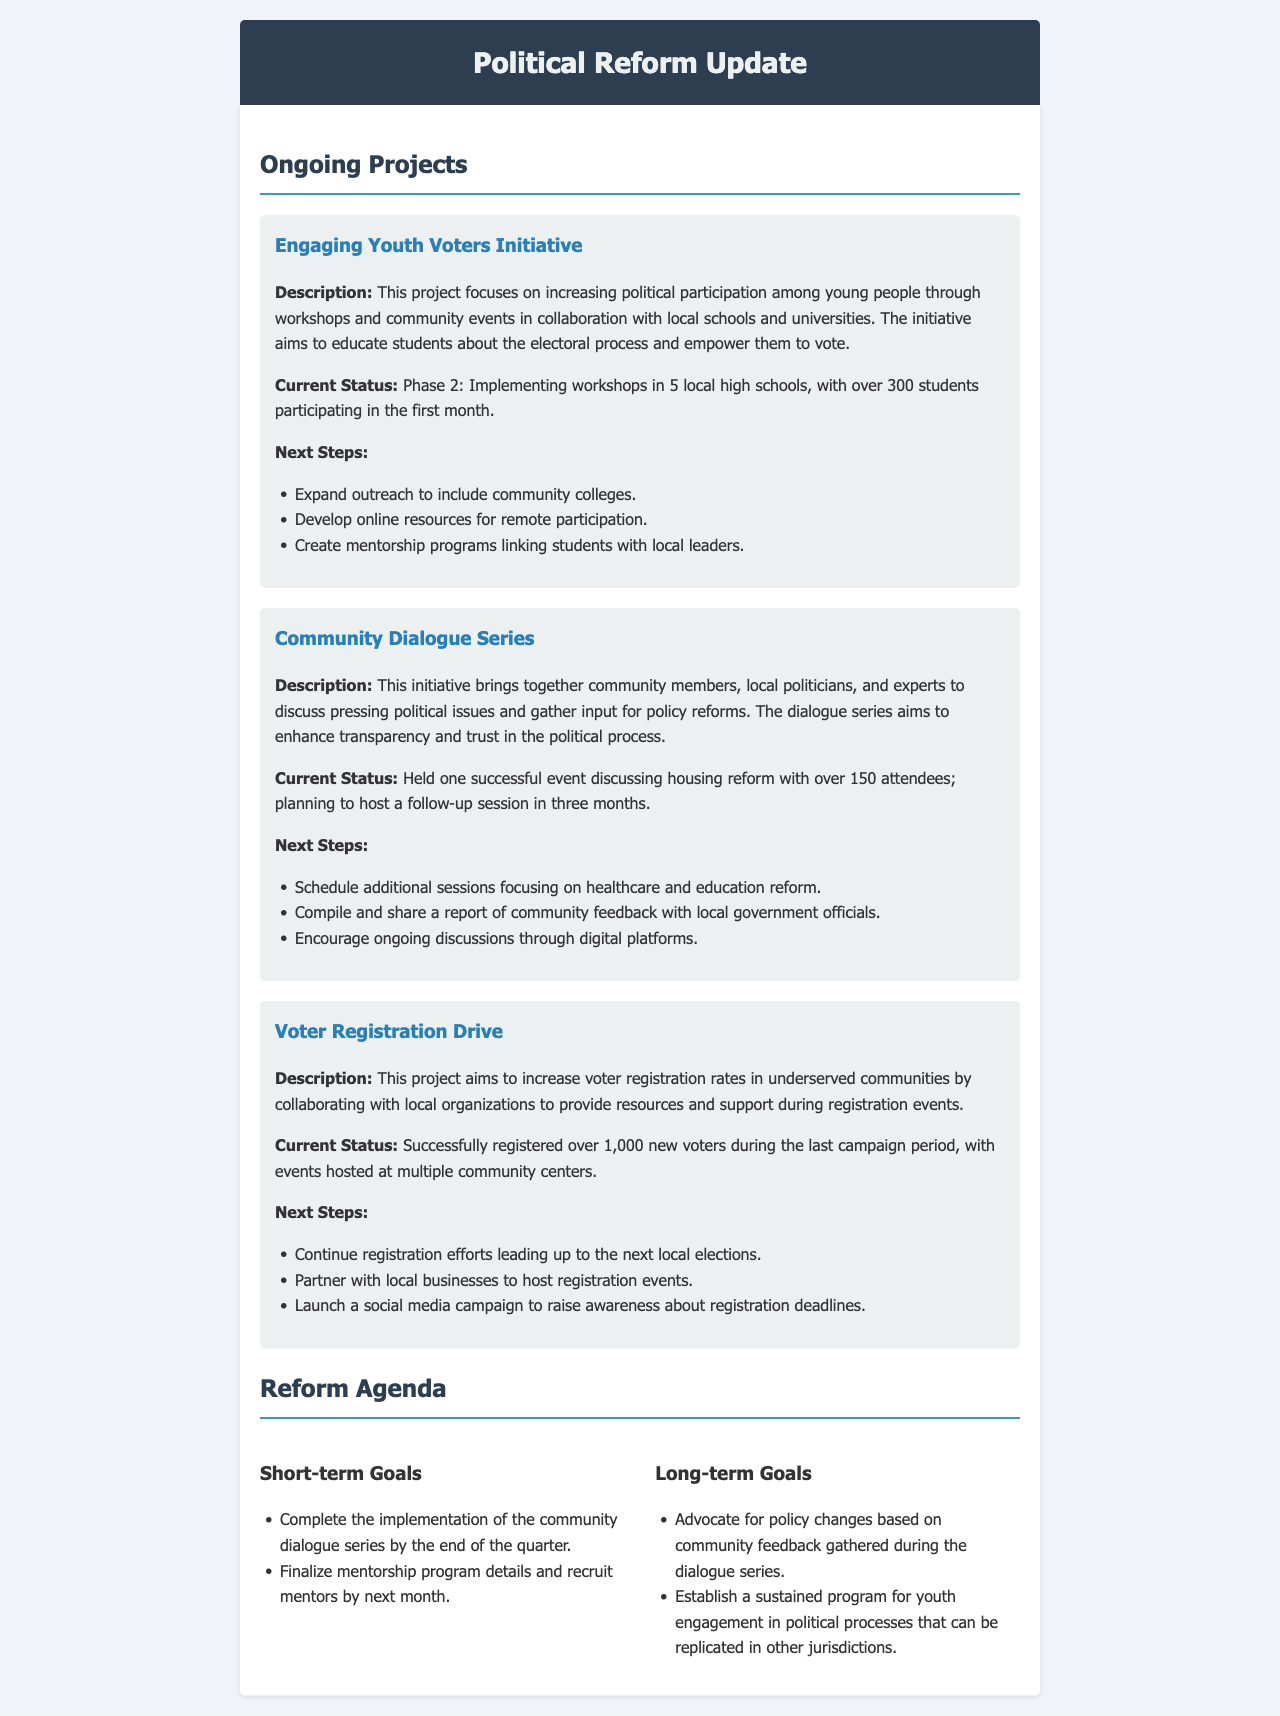what is the name of the initiative aimed at increasing political participation among young people? The initiative focuses on workshops and community events to educate students about the electoral process.
Answer: Engaging Youth Voters Initiative how many students participated in the first month of the Engaging Youth Voters Initiative? The document states that over 300 students participated in the first month.
Answer: over 300 what was discussed during the Community Dialogue Series event? The event discussed pressing political issues, specifically focused on a type of reform.
Answer: housing reform how many attendees were at the housing reform event? The document indicates that there were a specific number of attendees at the event.
Answer: over 150 what was the status of voter registration during the last campaign period? The document describes the outcome of the voter registration efforts with a specific number.
Answer: over 1,000 new voters what are the next steps planned for the Voter Registration Drive? The document outlines future actions related to voter registration efforts.
Answer: Continue registration efforts leading up to the next local elections what is one of the short-term goals listed in the reform agenda? The document specifies goals that need to be completed within a certain time frame.
Answer: Complete the implementation of the community dialogue series by the end of the quarter what type of program is planned for youth engagement that could be replicated? The document mentions an ongoing effort related to youth participation in a political context.
Answer: sustained program for youth engagement in political processes 